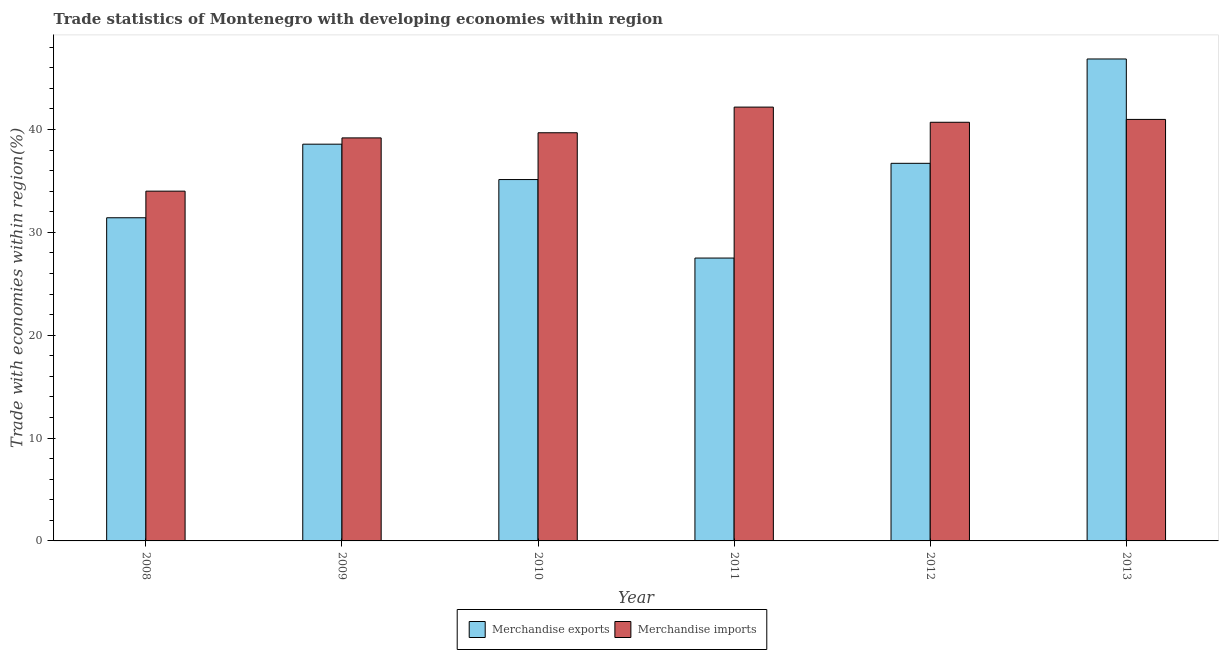How many different coloured bars are there?
Your answer should be very brief. 2. How many groups of bars are there?
Offer a terse response. 6. Are the number of bars on each tick of the X-axis equal?
Offer a terse response. Yes. How many bars are there on the 5th tick from the left?
Your response must be concise. 2. How many bars are there on the 1st tick from the right?
Your answer should be compact. 2. What is the label of the 5th group of bars from the left?
Provide a succinct answer. 2012. In how many cases, is the number of bars for a given year not equal to the number of legend labels?
Your answer should be very brief. 0. What is the merchandise exports in 2008?
Keep it short and to the point. 31.42. Across all years, what is the maximum merchandise imports?
Offer a very short reply. 42.17. Across all years, what is the minimum merchandise imports?
Offer a terse response. 34. In which year was the merchandise exports maximum?
Your response must be concise. 2013. In which year was the merchandise imports minimum?
Your response must be concise. 2008. What is the total merchandise exports in the graph?
Provide a succinct answer. 216.17. What is the difference between the merchandise imports in 2009 and that in 2013?
Keep it short and to the point. -1.8. What is the difference between the merchandise exports in 2012 and the merchandise imports in 2009?
Provide a short and direct response. -1.86. What is the average merchandise exports per year?
Give a very brief answer. 36.03. In the year 2009, what is the difference between the merchandise exports and merchandise imports?
Offer a very short reply. 0. What is the ratio of the merchandise imports in 2010 to that in 2013?
Keep it short and to the point. 0.97. Is the merchandise exports in 2009 less than that in 2010?
Give a very brief answer. No. Is the difference between the merchandise imports in 2009 and 2013 greater than the difference between the merchandise exports in 2009 and 2013?
Provide a succinct answer. No. What is the difference between the highest and the second highest merchandise imports?
Provide a succinct answer. 1.2. What is the difference between the highest and the lowest merchandise imports?
Give a very brief answer. 8.17. In how many years, is the merchandise imports greater than the average merchandise imports taken over all years?
Your answer should be very brief. 4. Is the sum of the merchandise imports in 2012 and 2013 greater than the maximum merchandise exports across all years?
Provide a short and direct response. Yes. What does the 1st bar from the left in 2011 represents?
Make the answer very short. Merchandise exports. What does the 1st bar from the right in 2012 represents?
Your answer should be very brief. Merchandise imports. How many bars are there?
Make the answer very short. 12. Are all the bars in the graph horizontal?
Provide a succinct answer. No. What is the difference between two consecutive major ticks on the Y-axis?
Your answer should be compact. 10. Does the graph contain any zero values?
Keep it short and to the point. No. Where does the legend appear in the graph?
Your response must be concise. Bottom center. How many legend labels are there?
Your response must be concise. 2. How are the legend labels stacked?
Give a very brief answer. Horizontal. What is the title of the graph?
Keep it short and to the point. Trade statistics of Montenegro with developing economies within region. Does "RDB nonconcessional" appear as one of the legend labels in the graph?
Offer a very short reply. No. What is the label or title of the Y-axis?
Your response must be concise. Trade with economies within region(%). What is the Trade with economies within region(%) of Merchandise exports in 2008?
Provide a short and direct response. 31.42. What is the Trade with economies within region(%) of Merchandise imports in 2008?
Provide a short and direct response. 34. What is the Trade with economies within region(%) of Merchandise exports in 2009?
Provide a succinct answer. 38.57. What is the Trade with economies within region(%) in Merchandise imports in 2009?
Provide a short and direct response. 39.18. What is the Trade with economies within region(%) in Merchandise exports in 2010?
Offer a very short reply. 35.13. What is the Trade with economies within region(%) of Merchandise imports in 2010?
Offer a very short reply. 39.68. What is the Trade with economies within region(%) of Merchandise exports in 2011?
Ensure brevity in your answer.  27.5. What is the Trade with economies within region(%) in Merchandise imports in 2011?
Offer a terse response. 42.17. What is the Trade with economies within region(%) in Merchandise exports in 2012?
Make the answer very short. 36.71. What is the Trade with economies within region(%) in Merchandise imports in 2012?
Keep it short and to the point. 40.7. What is the Trade with economies within region(%) in Merchandise exports in 2013?
Give a very brief answer. 46.85. What is the Trade with economies within region(%) of Merchandise imports in 2013?
Your response must be concise. 40.98. Across all years, what is the maximum Trade with economies within region(%) of Merchandise exports?
Ensure brevity in your answer.  46.85. Across all years, what is the maximum Trade with economies within region(%) of Merchandise imports?
Offer a terse response. 42.17. Across all years, what is the minimum Trade with economies within region(%) in Merchandise exports?
Offer a very short reply. 27.5. Across all years, what is the minimum Trade with economies within region(%) of Merchandise imports?
Offer a very short reply. 34. What is the total Trade with economies within region(%) in Merchandise exports in the graph?
Keep it short and to the point. 216.17. What is the total Trade with economies within region(%) in Merchandise imports in the graph?
Ensure brevity in your answer.  236.71. What is the difference between the Trade with economies within region(%) of Merchandise exports in 2008 and that in 2009?
Make the answer very short. -7.15. What is the difference between the Trade with economies within region(%) in Merchandise imports in 2008 and that in 2009?
Keep it short and to the point. -5.18. What is the difference between the Trade with economies within region(%) of Merchandise exports in 2008 and that in 2010?
Make the answer very short. -3.71. What is the difference between the Trade with economies within region(%) of Merchandise imports in 2008 and that in 2010?
Offer a terse response. -5.68. What is the difference between the Trade with economies within region(%) in Merchandise exports in 2008 and that in 2011?
Provide a short and direct response. 3.92. What is the difference between the Trade with economies within region(%) in Merchandise imports in 2008 and that in 2011?
Your response must be concise. -8.17. What is the difference between the Trade with economies within region(%) in Merchandise exports in 2008 and that in 2012?
Provide a succinct answer. -5.29. What is the difference between the Trade with economies within region(%) of Merchandise imports in 2008 and that in 2012?
Ensure brevity in your answer.  -6.7. What is the difference between the Trade with economies within region(%) in Merchandise exports in 2008 and that in 2013?
Give a very brief answer. -15.44. What is the difference between the Trade with economies within region(%) in Merchandise imports in 2008 and that in 2013?
Provide a short and direct response. -6.97. What is the difference between the Trade with economies within region(%) in Merchandise exports in 2009 and that in 2010?
Your answer should be very brief. 3.44. What is the difference between the Trade with economies within region(%) of Merchandise imports in 2009 and that in 2010?
Your response must be concise. -0.5. What is the difference between the Trade with economies within region(%) in Merchandise exports in 2009 and that in 2011?
Your answer should be compact. 11.07. What is the difference between the Trade with economies within region(%) in Merchandise imports in 2009 and that in 2011?
Offer a very short reply. -2.99. What is the difference between the Trade with economies within region(%) in Merchandise exports in 2009 and that in 2012?
Your answer should be very brief. 1.86. What is the difference between the Trade with economies within region(%) in Merchandise imports in 2009 and that in 2012?
Keep it short and to the point. -1.52. What is the difference between the Trade with economies within region(%) in Merchandise exports in 2009 and that in 2013?
Offer a very short reply. -8.28. What is the difference between the Trade with economies within region(%) of Merchandise imports in 2009 and that in 2013?
Provide a short and direct response. -1.8. What is the difference between the Trade with economies within region(%) in Merchandise exports in 2010 and that in 2011?
Provide a short and direct response. 7.63. What is the difference between the Trade with economies within region(%) of Merchandise imports in 2010 and that in 2011?
Keep it short and to the point. -2.49. What is the difference between the Trade with economies within region(%) in Merchandise exports in 2010 and that in 2012?
Make the answer very short. -1.58. What is the difference between the Trade with economies within region(%) of Merchandise imports in 2010 and that in 2012?
Make the answer very short. -1.02. What is the difference between the Trade with economies within region(%) of Merchandise exports in 2010 and that in 2013?
Offer a terse response. -11.72. What is the difference between the Trade with economies within region(%) in Merchandise imports in 2010 and that in 2013?
Ensure brevity in your answer.  -1.3. What is the difference between the Trade with economies within region(%) in Merchandise exports in 2011 and that in 2012?
Provide a succinct answer. -9.21. What is the difference between the Trade with economies within region(%) in Merchandise imports in 2011 and that in 2012?
Offer a terse response. 1.47. What is the difference between the Trade with economies within region(%) of Merchandise exports in 2011 and that in 2013?
Offer a terse response. -19.35. What is the difference between the Trade with economies within region(%) of Merchandise imports in 2011 and that in 2013?
Keep it short and to the point. 1.2. What is the difference between the Trade with economies within region(%) of Merchandise exports in 2012 and that in 2013?
Offer a very short reply. -10.14. What is the difference between the Trade with economies within region(%) of Merchandise imports in 2012 and that in 2013?
Provide a succinct answer. -0.28. What is the difference between the Trade with economies within region(%) of Merchandise exports in 2008 and the Trade with economies within region(%) of Merchandise imports in 2009?
Your answer should be compact. -7.76. What is the difference between the Trade with economies within region(%) of Merchandise exports in 2008 and the Trade with economies within region(%) of Merchandise imports in 2010?
Make the answer very short. -8.26. What is the difference between the Trade with economies within region(%) in Merchandise exports in 2008 and the Trade with economies within region(%) in Merchandise imports in 2011?
Ensure brevity in your answer.  -10.76. What is the difference between the Trade with economies within region(%) of Merchandise exports in 2008 and the Trade with economies within region(%) of Merchandise imports in 2012?
Make the answer very short. -9.28. What is the difference between the Trade with economies within region(%) of Merchandise exports in 2008 and the Trade with economies within region(%) of Merchandise imports in 2013?
Provide a succinct answer. -9.56. What is the difference between the Trade with economies within region(%) of Merchandise exports in 2009 and the Trade with economies within region(%) of Merchandise imports in 2010?
Your answer should be very brief. -1.11. What is the difference between the Trade with economies within region(%) in Merchandise exports in 2009 and the Trade with economies within region(%) in Merchandise imports in 2011?
Your answer should be compact. -3.61. What is the difference between the Trade with economies within region(%) of Merchandise exports in 2009 and the Trade with economies within region(%) of Merchandise imports in 2012?
Provide a succinct answer. -2.13. What is the difference between the Trade with economies within region(%) of Merchandise exports in 2009 and the Trade with economies within region(%) of Merchandise imports in 2013?
Your answer should be compact. -2.41. What is the difference between the Trade with economies within region(%) of Merchandise exports in 2010 and the Trade with economies within region(%) of Merchandise imports in 2011?
Your answer should be compact. -7.04. What is the difference between the Trade with economies within region(%) in Merchandise exports in 2010 and the Trade with economies within region(%) in Merchandise imports in 2012?
Provide a succinct answer. -5.57. What is the difference between the Trade with economies within region(%) of Merchandise exports in 2010 and the Trade with economies within region(%) of Merchandise imports in 2013?
Keep it short and to the point. -5.85. What is the difference between the Trade with economies within region(%) of Merchandise exports in 2011 and the Trade with economies within region(%) of Merchandise imports in 2012?
Offer a terse response. -13.2. What is the difference between the Trade with economies within region(%) in Merchandise exports in 2011 and the Trade with economies within region(%) in Merchandise imports in 2013?
Give a very brief answer. -13.48. What is the difference between the Trade with economies within region(%) of Merchandise exports in 2012 and the Trade with economies within region(%) of Merchandise imports in 2013?
Your answer should be compact. -4.27. What is the average Trade with economies within region(%) in Merchandise exports per year?
Your answer should be very brief. 36.03. What is the average Trade with economies within region(%) of Merchandise imports per year?
Offer a very short reply. 39.45. In the year 2008, what is the difference between the Trade with economies within region(%) of Merchandise exports and Trade with economies within region(%) of Merchandise imports?
Give a very brief answer. -2.59. In the year 2009, what is the difference between the Trade with economies within region(%) of Merchandise exports and Trade with economies within region(%) of Merchandise imports?
Your response must be concise. -0.61. In the year 2010, what is the difference between the Trade with economies within region(%) in Merchandise exports and Trade with economies within region(%) in Merchandise imports?
Your answer should be compact. -4.55. In the year 2011, what is the difference between the Trade with economies within region(%) in Merchandise exports and Trade with economies within region(%) in Merchandise imports?
Provide a short and direct response. -14.68. In the year 2012, what is the difference between the Trade with economies within region(%) in Merchandise exports and Trade with economies within region(%) in Merchandise imports?
Keep it short and to the point. -3.99. In the year 2013, what is the difference between the Trade with economies within region(%) of Merchandise exports and Trade with economies within region(%) of Merchandise imports?
Your response must be concise. 5.87. What is the ratio of the Trade with economies within region(%) in Merchandise exports in 2008 to that in 2009?
Offer a terse response. 0.81. What is the ratio of the Trade with economies within region(%) in Merchandise imports in 2008 to that in 2009?
Keep it short and to the point. 0.87. What is the ratio of the Trade with economies within region(%) in Merchandise exports in 2008 to that in 2010?
Ensure brevity in your answer.  0.89. What is the ratio of the Trade with economies within region(%) in Merchandise imports in 2008 to that in 2010?
Provide a short and direct response. 0.86. What is the ratio of the Trade with economies within region(%) of Merchandise exports in 2008 to that in 2011?
Give a very brief answer. 1.14. What is the ratio of the Trade with economies within region(%) of Merchandise imports in 2008 to that in 2011?
Make the answer very short. 0.81. What is the ratio of the Trade with economies within region(%) in Merchandise exports in 2008 to that in 2012?
Your response must be concise. 0.86. What is the ratio of the Trade with economies within region(%) of Merchandise imports in 2008 to that in 2012?
Offer a terse response. 0.84. What is the ratio of the Trade with economies within region(%) in Merchandise exports in 2008 to that in 2013?
Your response must be concise. 0.67. What is the ratio of the Trade with economies within region(%) of Merchandise imports in 2008 to that in 2013?
Ensure brevity in your answer.  0.83. What is the ratio of the Trade with economies within region(%) in Merchandise exports in 2009 to that in 2010?
Your answer should be compact. 1.1. What is the ratio of the Trade with economies within region(%) of Merchandise imports in 2009 to that in 2010?
Offer a very short reply. 0.99. What is the ratio of the Trade with economies within region(%) of Merchandise exports in 2009 to that in 2011?
Your response must be concise. 1.4. What is the ratio of the Trade with economies within region(%) of Merchandise imports in 2009 to that in 2011?
Offer a terse response. 0.93. What is the ratio of the Trade with economies within region(%) of Merchandise exports in 2009 to that in 2012?
Make the answer very short. 1.05. What is the ratio of the Trade with economies within region(%) of Merchandise imports in 2009 to that in 2012?
Offer a terse response. 0.96. What is the ratio of the Trade with economies within region(%) of Merchandise exports in 2009 to that in 2013?
Offer a terse response. 0.82. What is the ratio of the Trade with economies within region(%) of Merchandise imports in 2009 to that in 2013?
Your response must be concise. 0.96. What is the ratio of the Trade with economies within region(%) in Merchandise exports in 2010 to that in 2011?
Your answer should be very brief. 1.28. What is the ratio of the Trade with economies within region(%) of Merchandise imports in 2010 to that in 2011?
Make the answer very short. 0.94. What is the ratio of the Trade with economies within region(%) in Merchandise imports in 2010 to that in 2012?
Offer a terse response. 0.97. What is the ratio of the Trade with economies within region(%) in Merchandise exports in 2010 to that in 2013?
Provide a short and direct response. 0.75. What is the ratio of the Trade with economies within region(%) in Merchandise imports in 2010 to that in 2013?
Offer a very short reply. 0.97. What is the ratio of the Trade with economies within region(%) of Merchandise exports in 2011 to that in 2012?
Your response must be concise. 0.75. What is the ratio of the Trade with economies within region(%) in Merchandise imports in 2011 to that in 2012?
Offer a very short reply. 1.04. What is the ratio of the Trade with economies within region(%) of Merchandise exports in 2011 to that in 2013?
Provide a short and direct response. 0.59. What is the ratio of the Trade with economies within region(%) of Merchandise imports in 2011 to that in 2013?
Keep it short and to the point. 1.03. What is the ratio of the Trade with economies within region(%) of Merchandise exports in 2012 to that in 2013?
Your response must be concise. 0.78. What is the difference between the highest and the second highest Trade with economies within region(%) of Merchandise exports?
Provide a succinct answer. 8.28. What is the difference between the highest and the second highest Trade with economies within region(%) in Merchandise imports?
Your response must be concise. 1.2. What is the difference between the highest and the lowest Trade with economies within region(%) in Merchandise exports?
Provide a short and direct response. 19.35. What is the difference between the highest and the lowest Trade with economies within region(%) of Merchandise imports?
Keep it short and to the point. 8.17. 